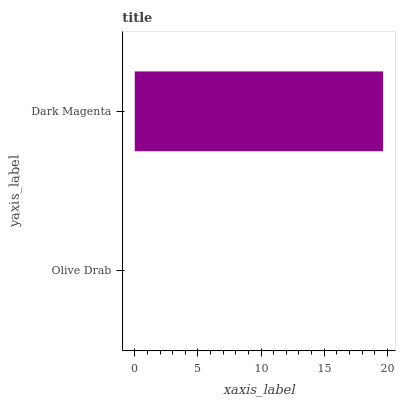Is Olive Drab the minimum?
Answer yes or no. Yes. Is Dark Magenta the maximum?
Answer yes or no. Yes. Is Dark Magenta the minimum?
Answer yes or no. No. Is Dark Magenta greater than Olive Drab?
Answer yes or no. Yes. Is Olive Drab less than Dark Magenta?
Answer yes or no. Yes. Is Olive Drab greater than Dark Magenta?
Answer yes or no. No. Is Dark Magenta less than Olive Drab?
Answer yes or no. No. Is Dark Magenta the high median?
Answer yes or no. Yes. Is Olive Drab the low median?
Answer yes or no. Yes. Is Olive Drab the high median?
Answer yes or no. No. Is Dark Magenta the low median?
Answer yes or no. No. 